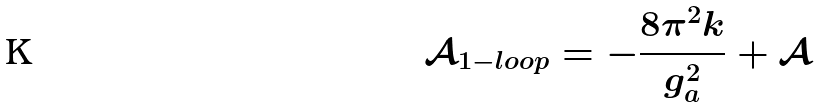Convert formula to latex. <formula><loc_0><loc_0><loc_500><loc_500>\mathcal { A } _ { 1 - l o o p } = - \frac { 8 \pi ^ { 2 } k } { g _ { a } ^ { 2 } } + \mathcal { A }</formula> 